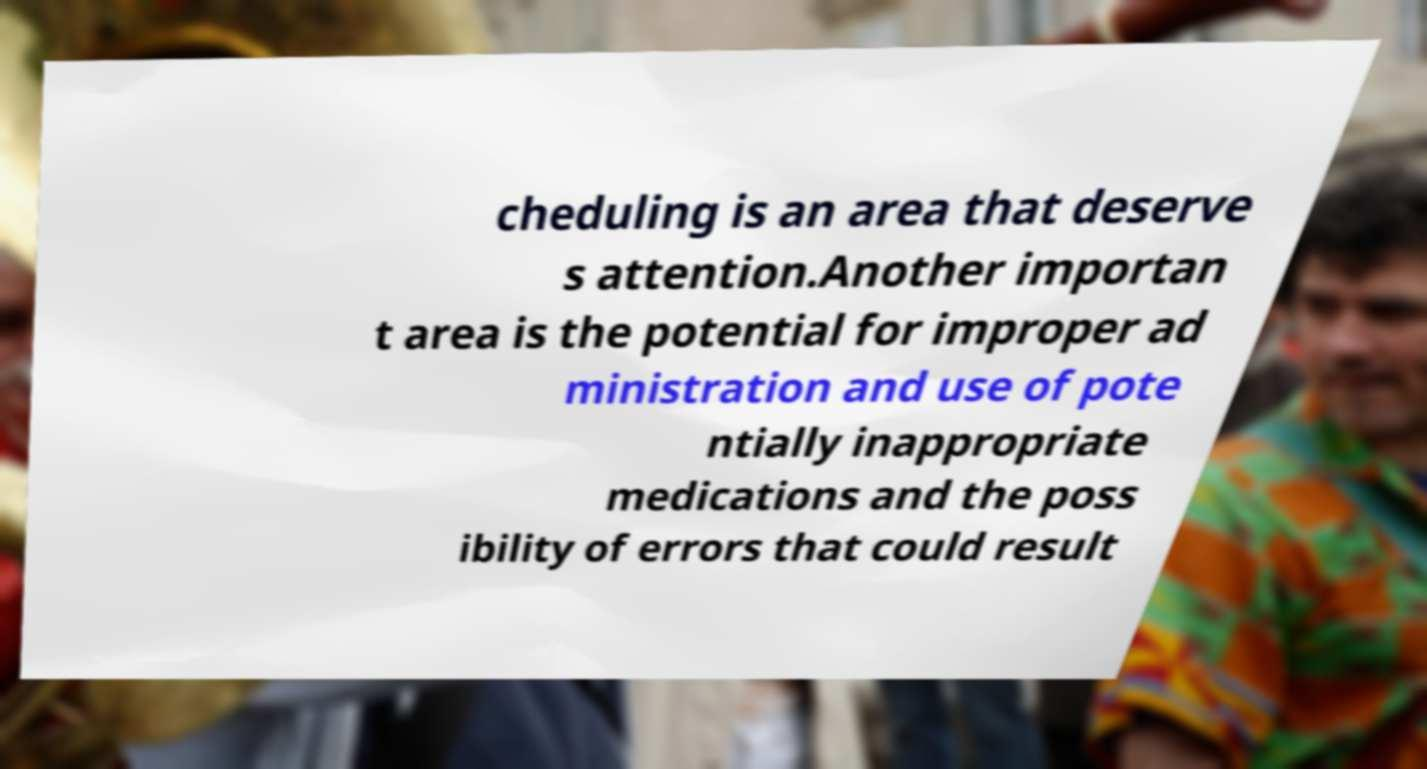Can you read and provide the text displayed in the image?This photo seems to have some interesting text. Can you extract and type it out for me? cheduling is an area that deserve s attention.Another importan t area is the potential for improper ad ministration and use of pote ntially inappropriate medications and the poss ibility of errors that could result 